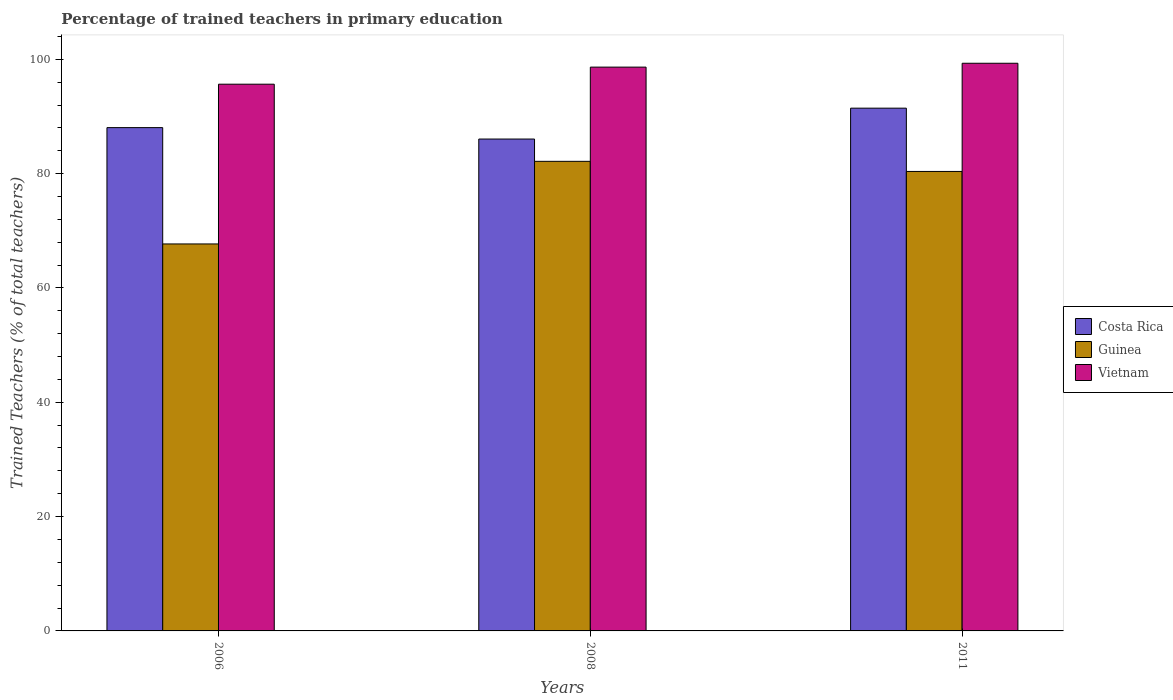Are the number of bars per tick equal to the number of legend labels?
Offer a terse response. Yes. What is the label of the 2nd group of bars from the left?
Give a very brief answer. 2008. In how many cases, is the number of bars for a given year not equal to the number of legend labels?
Ensure brevity in your answer.  0. What is the percentage of trained teachers in Vietnam in 2008?
Keep it short and to the point. 98.63. Across all years, what is the maximum percentage of trained teachers in Guinea?
Keep it short and to the point. 82.15. Across all years, what is the minimum percentage of trained teachers in Costa Rica?
Provide a succinct answer. 86.05. In which year was the percentage of trained teachers in Guinea maximum?
Provide a succinct answer. 2008. What is the total percentage of trained teachers in Vietnam in the graph?
Your answer should be compact. 293.57. What is the difference between the percentage of trained teachers in Vietnam in 2008 and that in 2011?
Provide a short and direct response. -0.68. What is the difference between the percentage of trained teachers in Guinea in 2008 and the percentage of trained teachers in Costa Rica in 2006?
Your answer should be very brief. -5.9. What is the average percentage of trained teachers in Vietnam per year?
Provide a succinct answer. 97.86. In the year 2006, what is the difference between the percentage of trained teachers in Guinea and percentage of trained teachers in Vietnam?
Offer a very short reply. -27.94. What is the ratio of the percentage of trained teachers in Vietnam in 2006 to that in 2011?
Offer a very short reply. 0.96. What is the difference between the highest and the second highest percentage of trained teachers in Vietnam?
Offer a very short reply. 0.68. What is the difference between the highest and the lowest percentage of trained teachers in Costa Rica?
Provide a short and direct response. 5.4. In how many years, is the percentage of trained teachers in Vietnam greater than the average percentage of trained teachers in Vietnam taken over all years?
Give a very brief answer. 2. What does the 3rd bar from the left in 2008 represents?
Offer a very short reply. Vietnam. What does the 1st bar from the right in 2006 represents?
Your response must be concise. Vietnam. Is it the case that in every year, the sum of the percentage of trained teachers in Costa Rica and percentage of trained teachers in Guinea is greater than the percentage of trained teachers in Vietnam?
Make the answer very short. Yes. How many bars are there?
Make the answer very short. 9. How many years are there in the graph?
Your response must be concise. 3. Are the values on the major ticks of Y-axis written in scientific E-notation?
Keep it short and to the point. No. Does the graph contain grids?
Your answer should be compact. No. Where does the legend appear in the graph?
Keep it short and to the point. Center right. How many legend labels are there?
Offer a very short reply. 3. What is the title of the graph?
Provide a short and direct response. Percentage of trained teachers in primary education. What is the label or title of the Y-axis?
Ensure brevity in your answer.  Trained Teachers (% of total teachers). What is the Trained Teachers (% of total teachers) in Costa Rica in 2006?
Provide a succinct answer. 88.04. What is the Trained Teachers (% of total teachers) of Guinea in 2006?
Your answer should be compact. 67.7. What is the Trained Teachers (% of total teachers) of Vietnam in 2006?
Offer a terse response. 95.64. What is the Trained Teachers (% of total teachers) of Costa Rica in 2008?
Ensure brevity in your answer.  86.05. What is the Trained Teachers (% of total teachers) in Guinea in 2008?
Keep it short and to the point. 82.15. What is the Trained Teachers (% of total teachers) of Vietnam in 2008?
Provide a short and direct response. 98.63. What is the Trained Teachers (% of total teachers) of Costa Rica in 2011?
Provide a succinct answer. 91.45. What is the Trained Teachers (% of total teachers) in Guinea in 2011?
Make the answer very short. 80.38. What is the Trained Teachers (% of total teachers) of Vietnam in 2011?
Your response must be concise. 99.3. Across all years, what is the maximum Trained Teachers (% of total teachers) of Costa Rica?
Make the answer very short. 91.45. Across all years, what is the maximum Trained Teachers (% of total teachers) in Guinea?
Keep it short and to the point. 82.15. Across all years, what is the maximum Trained Teachers (% of total teachers) of Vietnam?
Give a very brief answer. 99.3. Across all years, what is the minimum Trained Teachers (% of total teachers) of Costa Rica?
Offer a terse response. 86.05. Across all years, what is the minimum Trained Teachers (% of total teachers) in Guinea?
Provide a succinct answer. 67.7. Across all years, what is the minimum Trained Teachers (% of total teachers) of Vietnam?
Your answer should be very brief. 95.64. What is the total Trained Teachers (% of total teachers) in Costa Rica in the graph?
Provide a short and direct response. 265.54. What is the total Trained Teachers (% of total teachers) in Guinea in the graph?
Your answer should be very brief. 230.22. What is the total Trained Teachers (% of total teachers) of Vietnam in the graph?
Keep it short and to the point. 293.57. What is the difference between the Trained Teachers (% of total teachers) of Costa Rica in 2006 and that in 2008?
Make the answer very short. 2. What is the difference between the Trained Teachers (% of total teachers) of Guinea in 2006 and that in 2008?
Your answer should be compact. -14.45. What is the difference between the Trained Teachers (% of total teachers) of Vietnam in 2006 and that in 2008?
Your response must be concise. -2.99. What is the difference between the Trained Teachers (% of total teachers) of Costa Rica in 2006 and that in 2011?
Give a very brief answer. -3.4. What is the difference between the Trained Teachers (% of total teachers) in Guinea in 2006 and that in 2011?
Your response must be concise. -12.68. What is the difference between the Trained Teachers (% of total teachers) of Vietnam in 2006 and that in 2011?
Your response must be concise. -3.66. What is the difference between the Trained Teachers (% of total teachers) in Costa Rica in 2008 and that in 2011?
Offer a terse response. -5.4. What is the difference between the Trained Teachers (% of total teachers) in Guinea in 2008 and that in 2011?
Offer a very short reply. 1.77. What is the difference between the Trained Teachers (% of total teachers) of Vietnam in 2008 and that in 2011?
Offer a very short reply. -0.68. What is the difference between the Trained Teachers (% of total teachers) of Costa Rica in 2006 and the Trained Teachers (% of total teachers) of Guinea in 2008?
Ensure brevity in your answer.  5.9. What is the difference between the Trained Teachers (% of total teachers) in Costa Rica in 2006 and the Trained Teachers (% of total teachers) in Vietnam in 2008?
Ensure brevity in your answer.  -10.58. What is the difference between the Trained Teachers (% of total teachers) in Guinea in 2006 and the Trained Teachers (% of total teachers) in Vietnam in 2008?
Offer a very short reply. -30.93. What is the difference between the Trained Teachers (% of total teachers) of Costa Rica in 2006 and the Trained Teachers (% of total teachers) of Guinea in 2011?
Give a very brief answer. 7.67. What is the difference between the Trained Teachers (% of total teachers) in Costa Rica in 2006 and the Trained Teachers (% of total teachers) in Vietnam in 2011?
Your answer should be very brief. -11.26. What is the difference between the Trained Teachers (% of total teachers) of Guinea in 2006 and the Trained Teachers (% of total teachers) of Vietnam in 2011?
Ensure brevity in your answer.  -31.61. What is the difference between the Trained Teachers (% of total teachers) of Costa Rica in 2008 and the Trained Teachers (% of total teachers) of Guinea in 2011?
Offer a very short reply. 5.67. What is the difference between the Trained Teachers (% of total teachers) of Costa Rica in 2008 and the Trained Teachers (% of total teachers) of Vietnam in 2011?
Offer a very short reply. -13.26. What is the difference between the Trained Teachers (% of total teachers) in Guinea in 2008 and the Trained Teachers (% of total teachers) in Vietnam in 2011?
Offer a terse response. -17.16. What is the average Trained Teachers (% of total teachers) of Costa Rica per year?
Offer a terse response. 88.51. What is the average Trained Teachers (% of total teachers) in Guinea per year?
Your response must be concise. 76.74. What is the average Trained Teachers (% of total teachers) of Vietnam per year?
Your answer should be compact. 97.86. In the year 2006, what is the difference between the Trained Teachers (% of total teachers) in Costa Rica and Trained Teachers (% of total teachers) in Guinea?
Your response must be concise. 20.35. In the year 2006, what is the difference between the Trained Teachers (% of total teachers) of Costa Rica and Trained Teachers (% of total teachers) of Vietnam?
Your answer should be compact. -7.6. In the year 2006, what is the difference between the Trained Teachers (% of total teachers) in Guinea and Trained Teachers (% of total teachers) in Vietnam?
Offer a very short reply. -27.94. In the year 2008, what is the difference between the Trained Teachers (% of total teachers) of Costa Rica and Trained Teachers (% of total teachers) of Guinea?
Keep it short and to the point. 3.9. In the year 2008, what is the difference between the Trained Teachers (% of total teachers) of Costa Rica and Trained Teachers (% of total teachers) of Vietnam?
Offer a terse response. -12.58. In the year 2008, what is the difference between the Trained Teachers (% of total teachers) in Guinea and Trained Teachers (% of total teachers) in Vietnam?
Offer a terse response. -16.48. In the year 2011, what is the difference between the Trained Teachers (% of total teachers) in Costa Rica and Trained Teachers (% of total teachers) in Guinea?
Provide a short and direct response. 11.07. In the year 2011, what is the difference between the Trained Teachers (% of total teachers) of Costa Rica and Trained Teachers (% of total teachers) of Vietnam?
Give a very brief answer. -7.85. In the year 2011, what is the difference between the Trained Teachers (% of total teachers) of Guinea and Trained Teachers (% of total teachers) of Vietnam?
Offer a very short reply. -18.93. What is the ratio of the Trained Teachers (% of total teachers) in Costa Rica in 2006 to that in 2008?
Your answer should be compact. 1.02. What is the ratio of the Trained Teachers (% of total teachers) in Guinea in 2006 to that in 2008?
Offer a very short reply. 0.82. What is the ratio of the Trained Teachers (% of total teachers) in Vietnam in 2006 to that in 2008?
Your answer should be very brief. 0.97. What is the ratio of the Trained Teachers (% of total teachers) of Costa Rica in 2006 to that in 2011?
Make the answer very short. 0.96. What is the ratio of the Trained Teachers (% of total teachers) of Guinea in 2006 to that in 2011?
Ensure brevity in your answer.  0.84. What is the ratio of the Trained Teachers (% of total teachers) of Vietnam in 2006 to that in 2011?
Provide a succinct answer. 0.96. What is the ratio of the Trained Teachers (% of total teachers) of Costa Rica in 2008 to that in 2011?
Offer a very short reply. 0.94. What is the difference between the highest and the second highest Trained Teachers (% of total teachers) of Costa Rica?
Ensure brevity in your answer.  3.4. What is the difference between the highest and the second highest Trained Teachers (% of total teachers) in Guinea?
Offer a very short reply. 1.77. What is the difference between the highest and the second highest Trained Teachers (% of total teachers) in Vietnam?
Your response must be concise. 0.68. What is the difference between the highest and the lowest Trained Teachers (% of total teachers) of Costa Rica?
Offer a very short reply. 5.4. What is the difference between the highest and the lowest Trained Teachers (% of total teachers) in Guinea?
Provide a succinct answer. 14.45. What is the difference between the highest and the lowest Trained Teachers (% of total teachers) of Vietnam?
Give a very brief answer. 3.66. 